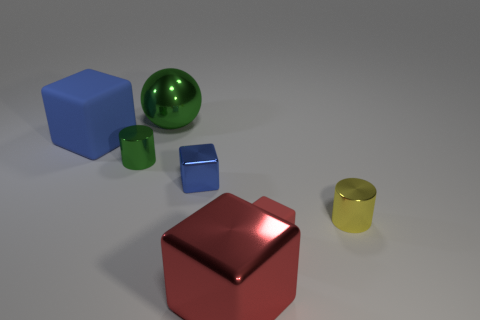Subtract all small metallic blocks. How many blocks are left? 3 Subtract all cyan spheres. How many red blocks are left? 2 Add 2 metallic cubes. How many objects exist? 9 Subtract all purple blocks. Subtract all red cylinders. How many blocks are left? 4 Subtract all balls. How many objects are left? 6 Subtract 1 yellow cylinders. How many objects are left? 6 Subtract all red objects. Subtract all tiny purple blocks. How many objects are left? 5 Add 1 small blue metallic objects. How many small blue metallic objects are left? 2 Add 6 tiny cyan cylinders. How many tiny cyan cylinders exist? 6 